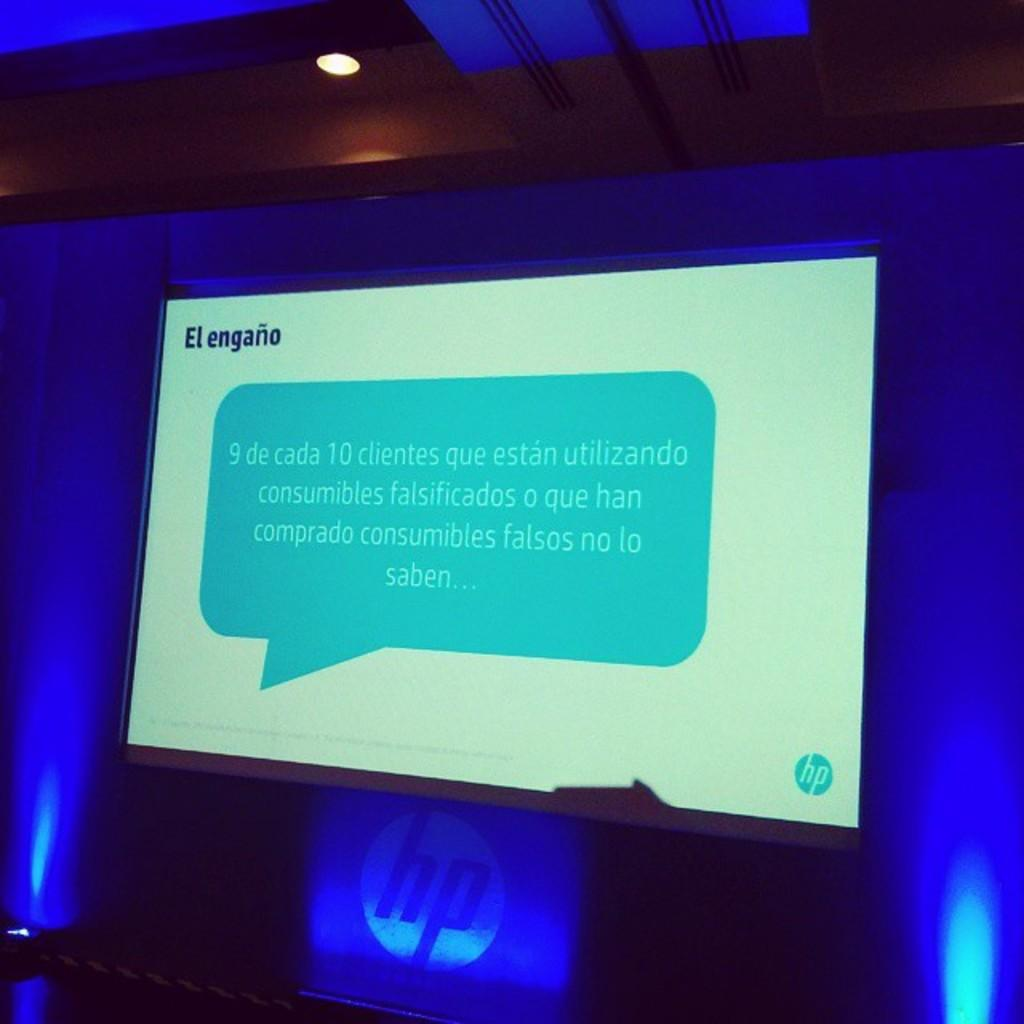<image>
Offer a succinct explanation of the picture presented. a computer screen with engano over a blue speech bubble. 